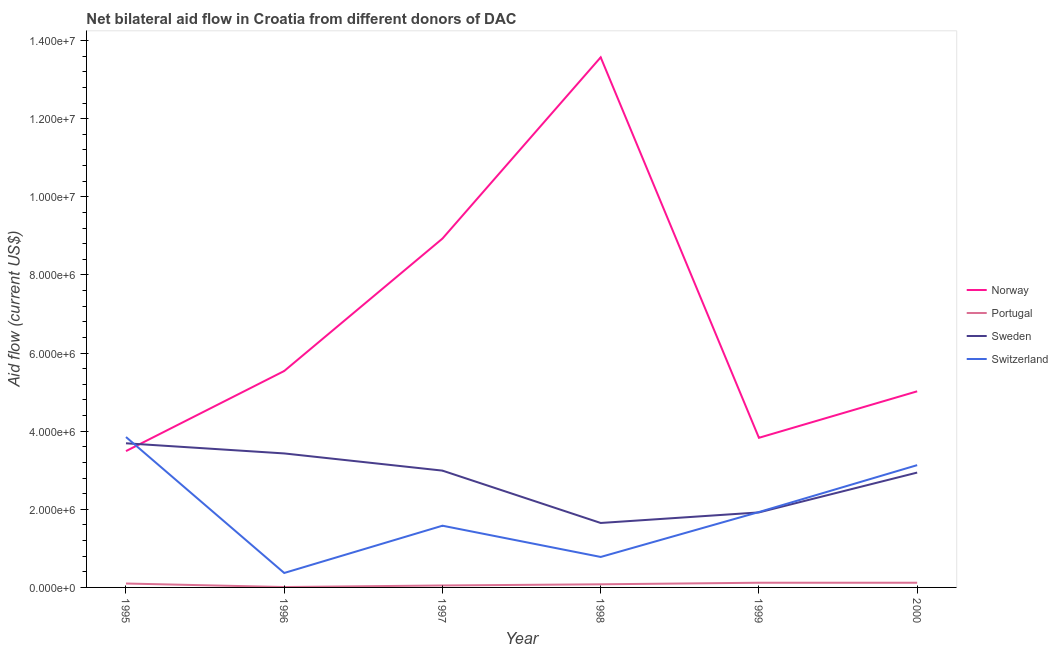How many different coloured lines are there?
Give a very brief answer. 4. Does the line corresponding to amount of aid given by norway intersect with the line corresponding to amount of aid given by sweden?
Make the answer very short. Yes. What is the amount of aid given by sweden in 1997?
Offer a very short reply. 2.99e+06. Across all years, what is the maximum amount of aid given by portugal?
Your answer should be compact. 1.20e+05. Across all years, what is the minimum amount of aid given by switzerland?
Offer a terse response. 3.70e+05. What is the total amount of aid given by norway in the graph?
Offer a very short reply. 4.04e+07. What is the difference between the amount of aid given by portugal in 1995 and that in 1996?
Give a very brief answer. 9.00e+04. What is the difference between the amount of aid given by portugal in 1997 and the amount of aid given by sweden in 1999?
Give a very brief answer. -1.87e+06. In the year 1996, what is the difference between the amount of aid given by switzerland and amount of aid given by sweden?
Provide a short and direct response. -3.06e+06. What is the ratio of the amount of aid given by switzerland in 1995 to that in 2000?
Keep it short and to the point. 1.23. What is the difference between the highest and the second highest amount of aid given by sweden?
Give a very brief answer. 2.60e+05. What is the difference between the highest and the lowest amount of aid given by sweden?
Give a very brief answer. 2.04e+06. Is the sum of the amount of aid given by switzerland in 1999 and 2000 greater than the maximum amount of aid given by portugal across all years?
Offer a very short reply. Yes. Is it the case that in every year, the sum of the amount of aid given by norway and amount of aid given by sweden is greater than the sum of amount of aid given by switzerland and amount of aid given by portugal?
Ensure brevity in your answer.  Yes. Is the amount of aid given by portugal strictly less than the amount of aid given by switzerland over the years?
Provide a short and direct response. Yes. How many lines are there?
Ensure brevity in your answer.  4. How many years are there in the graph?
Offer a very short reply. 6. What is the difference between two consecutive major ticks on the Y-axis?
Make the answer very short. 2.00e+06. Does the graph contain grids?
Your response must be concise. No. How are the legend labels stacked?
Ensure brevity in your answer.  Vertical. What is the title of the graph?
Your answer should be compact. Net bilateral aid flow in Croatia from different donors of DAC. What is the label or title of the X-axis?
Make the answer very short. Year. What is the Aid flow (current US$) in Norway in 1995?
Make the answer very short. 3.49e+06. What is the Aid flow (current US$) of Sweden in 1995?
Offer a very short reply. 3.69e+06. What is the Aid flow (current US$) in Switzerland in 1995?
Offer a terse response. 3.85e+06. What is the Aid flow (current US$) in Norway in 1996?
Provide a succinct answer. 5.54e+06. What is the Aid flow (current US$) of Sweden in 1996?
Offer a terse response. 3.43e+06. What is the Aid flow (current US$) of Norway in 1997?
Provide a succinct answer. 8.93e+06. What is the Aid flow (current US$) in Portugal in 1997?
Make the answer very short. 5.00e+04. What is the Aid flow (current US$) of Sweden in 1997?
Offer a very short reply. 2.99e+06. What is the Aid flow (current US$) in Switzerland in 1997?
Provide a short and direct response. 1.58e+06. What is the Aid flow (current US$) in Norway in 1998?
Offer a terse response. 1.36e+07. What is the Aid flow (current US$) in Portugal in 1998?
Ensure brevity in your answer.  8.00e+04. What is the Aid flow (current US$) of Sweden in 1998?
Give a very brief answer. 1.65e+06. What is the Aid flow (current US$) of Switzerland in 1998?
Your answer should be compact. 7.80e+05. What is the Aid flow (current US$) of Norway in 1999?
Give a very brief answer. 3.83e+06. What is the Aid flow (current US$) of Portugal in 1999?
Keep it short and to the point. 1.20e+05. What is the Aid flow (current US$) of Sweden in 1999?
Provide a succinct answer. 1.92e+06. What is the Aid flow (current US$) in Switzerland in 1999?
Give a very brief answer. 1.93e+06. What is the Aid flow (current US$) of Norway in 2000?
Provide a succinct answer. 5.02e+06. What is the Aid flow (current US$) of Portugal in 2000?
Provide a succinct answer. 1.20e+05. What is the Aid flow (current US$) of Sweden in 2000?
Ensure brevity in your answer.  2.94e+06. What is the Aid flow (current US$) of Switzerland in 2000?
Provide a succinct answer. 3.13e+06. Across all years, what is the maximum Aid flow (current US$) of Norway?
Provide a succinct answer. 1.36e+07. Across all years, what is the maximum Aid flow (current US$) in Sweden?
Give a very brief answer. 3.69e+06. Across all years, what is the maximum Aid flow (current US$) in Switzerland?
Provide a succinct answer. 3.85e+06. Across all years, what is the minimum Aid flow (current US$) in Norway?
Offer a very short reply. 3.49e+06. Across all years, what is the minimum Aid flow (current US$) in Portugal?
Your answer should be very brief. 10000. Across all years, what is the minimum Aid flow (current US$) of Sweden?
Your answer should be very brief. 1.65e+06. What is the total Aid flow (current US$) in Norway in the graph?
Offer a terse response. 4.04e+07. What is the total Aid flow (current US$) in Portugal in the graph?
Keep it short and to the point. 4.80e+05. What is the total Aid flow (current US$) of Sweden in the graph?
Keep it short and to the point. 1.66e+07. What is the total Aid flow (current US$) in Switzerland in the graph?
Give a very brief answer. 1.16e+07. What is the difference between the Aid flow (current US$) in Norway in 1995 and that in 1996?
Offer a terse response. -2.05e+06. What is the difference between the Aid flow (current US$) in Sweden in 1995 and that in 1996?
Your answer should be compact. 2.60e+05. What is the difference between the Aid flow (current US$) in Switzerland in 1995 and that in 1996?
Ensure brevity in your answer.  3.48e+06. What is the difference between the Aid flow (current US$) of Norway in 1995 and that in 1997?
Ensure brevity in your answer.  -5.44e+06. What is the difference between the Aid flow (current US$) in Switzerland in 1995 and that in 1997?
Offer a terse response. 2.27e+06. What is the difference between the Aid flow (current US$) of Norway in 1995 and that in 1998?
Offer a very short reply. -1.01e+07. What is the difference between the Aid flow (current US$) of Portugal in 1995 and that in 1998?
Make the answer very short. 2.00e+04. What is the difference between the Aid flow (current US$) in Sweden in 1995 and that in 1998?
Offer a terse response. 2.04e+06. What is the difference between the Aid flow (current US$) of Switzerland in 1995 and that in 1998?
Offer a very short reply. 3.07e+06. What is the difference between the Aid flow (current US$) of Norway in 1995 and that in 1999?
Provide a short and direct response. -3.40e+05. What is the difference between the Aid flow (current US$) of Portugal in 1995 and that in 1999?
Give a very brief answer. -2.00e+04. What is the difference between the Aid flow (current US$) of Sweden in 1995 and that in 1999?
Your response must be concise. 1.77e+06. What is the difference between the Aid flow (current US$) in Switzerland in 1995 and that in 1999?
Provide a short and direct response. 1.92e+06. What is the difference between the Aid flow (current US$) in Norway in 1995 and that in 2000?
Your answer should be very brief. -1.53e+06. What is the difference between the Aid flow (current US$) in Sweden in 1995 and that in 2000?
Ensure brevity in your answer.  7.50e+05. What is the difference between the Aid flow (current US$) in Switzerland in 1995 and that in 2000?
Provide a short and direct response. 7.20e+05. What is the difference between the Aid flow (current US$) in Norway in 1996 and that in 1997?
Provide a short and direct response. -3.39e+06. What is the difference between the Aid flow (current US$) in Sweden in 1996 and that in 1997?
Offer a very short reply. 4.40e+05. What is the difference between the Aid flow (current US$) in Switzerland in 1996 and that in 1997?
Your response must be concise. -1.21e+06. What is the difference between the Aid flow (current US$) in Norway in 1996 and that in 1998?
Provide a short and direct response. -8.03e+06. What is the difference between the Aid flow (current US$) of Sweden in 1996 and that in 1998?
Give a very brief answer. 1.78e+06. What is the difference between the Aid flow (current US$) in Switzerland in 1996 and that in 1998?
Your response must be concise. -4.10e+05. What is the difference between the Aid flow (current US$) in Norway in 1996 and that in 1999?
Your answer should be very brief. 1.71e+06. What is the difference between the Aid flow (current US$) in Portugal in 1996 and that in 1999?
Your answer should be compact. -1.10e+05. What is the difference between the Aid flow (current US$) of Sweden in 1996 and that in 1999?
Provide a succinct answer. 1.51e+06. What is the difference between the Aid flow (current US$) of Switzerland in 1996 and that in 1999?
Your answer should be compact. -1.56e+06. What is the difference between the Aid flow (current US$) in Norway in 1996 and that in 2000?
Your response must be concise. 5.20e+05. What is the difference between the Aid flow (current US$) in Switzerland in 1996 and that in 2000?
Your answer should be very brief. -2.76e+06. What is the difference between the Aid flow (current US$) of Norway in 1997 and that in 1998?
Make the answer very short. -4.64e+06. What is the difference between the Aid flow (current US$) in Sweden in 1997 and that in 1998?
Provide a succinct answer. 1.34e+06. What is the difference between the Aid flow (current US$) of Norway in 1997 and that in 1999?
Offer a terse response. 5.10e+06. What is the difference between the Aid flow (current US$) in Sweden in 1997 and that in 1999?
Ensure brevity in your answer.  1.07e+06. What is the difference between the Aid flow (current US$) of Switzerland in 1997 and that in 1999?
Give a very brief answer. -3.50e+05. What is the difference between the Aid flow (current US$) of Norway in 1997 and that in 2000?
Keep it short and to the point. 3.91e+06. What is the difference between the Aid flow (current US$) in Switzerland in 1997 and that in 2000?
Provide a succinct answer. -1.55e+06. What is the difference between the Aid flow (current US$) in Norway in 1998 and that in 1999?
Provide a succinct answer. 9.74e+06. What is the difference between the Aid flow (current US$) in Portugal in 1998 and that in 1999?
Your answer should be very brief. -4.00e+04. What is the difference between the Aid flow (current US$) of Sweden in 1998 and that in 1999?
Give a very brief answer. -2.70e+05. What is the difference between the Aid flow (current US$) in Switzerland in 1998 and that in 1999?
Your response must be concise. -1.15e+06. What is the difference between the Aid flow (current US$) in Norway in 1998 and that in 2000?
Ensure brevity in your answer.  8.55e+06. What is the difference between the Aid flow (current US$) of Sweden in 1998 and that in 2000?
Keep it short and to the point. -1.29e+06. What is the difference between the Aid flow (current US$) of Switzerland in 1998 and that in 2000?
Make the answer very short. -2.35e+06. What is the difference between the Aid flow (current US$) of Norway in 1999 and that in 2000?
Provide a succinct answer. -1.19e+06. What is the difference between the Aid flow (current US$) in Sweden in 1999 and that in 2000?
Offer a terse response. -1.02e+06. What is the difference between the Aid flow (current US$) of Switzerland in 1999 and that in 2000?
Ensure brevity in your answer.  -1.20e+06. What is the difference between the Aid flow (current US$) in Norway in 1995 and the Aid flow (current US$) in Portugal in 1996?
Ensure brevity in your answer.  3.48e+06. What is the difference between the Aid flow (current US$) of Norway in 1995 and the Aid flow (current US$) of Switzerland in 1996?
Make the answer very short. 3.12e+06. What is the difference between the Aid flow (current US$) of Portugal in 1995 and the Aid flow (current US$) of Sweden in 1996?
Keep it short and to the point. -3.33e+06. What is the difference between the Aid flow (current US$) of Portugal in 1995 and the Aid flow (current US$) of Switzerland in 1996?
Your answer should be very brief. -2.70e+05. What is the difference between the Aid flow (current US$) of Sweden in 1995 and the Aid flow (current US$) of Switzerland in 1996?
Your response must be concise. 3.32e+06. What is the difference between the Aid flow (current US$) in Norway in 1995 and the Aid flow (current US$) in Portugal in 1997?
Your answer should be very brief. 3.44e+06. What is the difference between the Aid flow (current US$) in Norway in 1995 and the Aid flow (current US$) in Sweden in 1997?
Provide a succinct answer. 5.00e+05. What is the difference between the Aid flow (current US$) of Norway in 1995 and the Aid flow (current US$) of Switzerland in 1997?
Offer a terse response. 1.91e+06. What is the difference between the Aid flow (current US$) of Portugal in 1995 and the Aid flow (current US$) of Sweden in 1997?
Make the answer very short. -2.89e+06. What is the difference between the Aid flow (current US$) of Portugal in 1995 and the Aid flow (current US$) of Switzerland in 1997?
Provide a short and direct response. -1.48e+06. What is the difference between the Aid flow (current US$) of Sweden in 1995 and the Aid flow (current US$) of Switzerland in 1997?
Ensure brevity in your answer.  2.11e+06. What is the difference between the Aid flow (current US$) of Norway in 1995 and the Aid flow (current US$) of Portugal in 1998?
Offer a very short reply. 3.41e+06. What is the difference between the Aid flow (current US$) of Norway in 1995 and the Aid flow (current US$) of Sweden in 1998?
Ensure brevity in your answer.  1.84e+06. What is the difference between the Aid flow (current US$) of Norway in 1995 and the Aid flow (current US$) of Switzerland in 1998?
Ensure brevity in your answer.  2.71e+06. What is the difference between the Aid flow (current US$) in Portugal in 1995 and the Aid flow (current US$) in Sweden in 1998?
Your answer should be very brief. -1.55e+06. What is the difference between the Aid flow (current US$) in Portugal in 1995 and the Aid flow (current US$) in Switzerland in 1998?
Offer a very short reply. -6.80e+05. What is the difference between the Aid flow (current US$) in Sweden in 1995 and the Aid flow (current US$) in Switzerland in 1998?
Ensure brevity in your answer.  2.91e+06. What is the difference between the Aid flow (current US$) of Norway in 1995 and the Aid flow (current US$) of Portugal in 1999?
Provide a succinct answer. 3.37e+06. What is the difference between the Aid flow (current US$) of Norway in 1995 and the Aid flow (current US$) of Sweden in 1999?
Provide a succinct answer. 1.57e+06. What is the difference between the Aid flow (current US$) in Norway in 1995 and the Aid flow (current US$) in Switzerland in 1999?
Your answer should be very brief. 1.56e+06. What is the difference between the Aid flow (current US$) of Portugal in 1995 and the Aid flow (current US$) of Sweden in 1999?
Provide a short and direct response. -1.82e+06. What is the difference between the Aid flow (current US$) in Portugal in 1995 and the Aid flow (current US$) in Switzerland in 1999?
Provide a short and direct response. -1.83e+06. What is the difference between the Aid flow (current US$) in Sweden in 1995 and the Aid flow (current US$) in Switzerland in 1999?
Ensure brevity in your answer.  1.76e+06. What is the difference between the Aid flow (current US$) of Norway in 1995 and the Aid flow (current US$) of Portugal in 2000?
Offer a very short reply. 3.37e+06. What is the difference between the Aid flow (current US$) of Norway in 1995 and the Aid flow (current US$) of Sweden in 2000?
Give a very brief answer. 5.50e+05. What is the difference between the Aid flow (current US$) of Portugal in 1995 and the Aid flow (current US$) of Sweden in 2000?
Provide a succinct answer. -2.84e+06. What is the difference between the Aid flow (current US$) in Portugal in 1995 and the Aid flow (current US$) in Switzerland in 2000?
Provide a short and direct response. -3.03e+06. What is the difference between the Aid flow (current US$) of Sweden in 1995 and the Aid flow (current US$) of Switzerland in 2000?
Your answer should be very brief. 5.60e+05. What is the difference between the Aid flow (current US$) of Norway in 1996 and the Aid flow (current US$) of Portugal in 1997?
Provide a short and direct response. 5.49e+06. What is the difference between the Aid flow (current US$) in Norway in 1996 and the Aid flow (current US$) in Sweden in 1997?
Your answer should be compact. 2.55e+06. What is the difference between the Aid flow (current US$) in Norway in 1996 and the Aid flow (current US$) in Switzerland in 1997?
Your answer should be very brief. 3.96e+06. What is the difference between the Aid flow (current US$) of Portugal in 1996 and the Aid flow (current US$) of Sweden in 1997?
Your response must be concise. -2.98e+06. What is the difference between the Aid flow (current US$) of Portugal in 1996 and the Aid flow (current US$) of Switzerland in 1997?
Offer a very short reply. -1.57e+06. What is the difference between the Aid flow (current US$) of Sweden in 1996 and the Aid flow (current US$) of Switzerland in 1997?
Your answer should be very brief. 1.85e+06. What is the difference between the Aid flow (current US$) in Norway in 1996 and the Aid flow (current US$) in Portugal in 1998?
Keep it short and to the point. 5.46e+06. What is the difference between the Aid flow (current US$) of Norway in 1996 and the Aid flow (current US$) of Sweden in 1998?
Your answer should be compact. 3.89e+06. What is the difference between the Aid flow (current US$) in Norway in 1996 and the Aid flow (current US$) in Switzerland in 1998?
Give a very brief answer. 4.76e+06. What is the difference between the Aid flow (current US$) in Portugal in 1996 and the Aid flow (current US$) in Sweden in 1998?
Your response must be concise. -1.64e+06. What is the difference between the Aid flow (current US$) of Portugal in 1996 and the Aid flow (current US$) of Switzerland in 1998?
Give a very brief answer. -7.70e+05. What is the difference between the Aid flow (current US$) in Sweden in 1996 and the Aid flow (current US$) in Switzerland in 1998?
Offer a very short reply. 2.65e+06. What is the difference between the Aid flow (current US$) in Norway in 1996 and the Aid flow (current US$) in Portugal in 1999?
Provide a succinct answer. 5.42e+06. What is the difference between the Aid flow (current US$) in Norway in 1996 and the Aid flow (current US$) in Sweden in 1999?
Ensure brevity in your answer.  3.62e+06. What is the difference between the Aid flow (current US$) of Norway in 1996 and the Aid flow (current US$) of Switzerland in 1999?
Provide a succinct answer. 3.61e+06. What is the difference between the Aid flow (current US$) of Portugal in 1996 and the Aid flow (current US$) of Sweden in 1999?
Your response must be concise. -1.91e+06. What is the difference between the Aid flow (current US$) in Portugal in 1996 and the Aid flow (current US$) in Switzerland in 1999?
Keep it short and to the point. -1.92e+06. What is the difference between the Aid flow (current US$) in Sweden in 1996 and the Aid flow (current US$) in Switzerland in 1999?
Make the answer very short. 1.50e+06. What is the difference between the Aid flow (current US$) in Norway in 1996 and the Aid flow (current US$) in Portugal in 2000?
Provide a succinct answer. 5.42e+06. What is the difference between the Aid flow (current US$) in Norway in 1996 and the Aid flow (current US$) in Sweden in 2000?
Offer a very short reply. 2.60e+06. What is the difference between the Aid flow (current US$) in Norway in 1996 and the Aid flow (current US$) in Switzerland in 2000?
Make the answer very short. 2.41e+06. What is the difference between the Aid flow (current US$) of Portugal in 1996 and the Aid flow (current US$) of Sweden in 2000?
Your answer should be very brief. -2.93e+06. What is the difference between the Aid flow (current US$) of Portugal in 1996 and the Aid flow (current US$) of Switzerland in 2000?
Your answer should be compact. -3.12e+06. What is the difference between the Aid flow (current US$) in Sweden in 1996 and the Aid flow (current US$) in Switzerland in 2000?
Your answer should be compact. 3.00e+05. What is the difference between the Aid flow (current US$) in Norway in 1997 and the Aid flow (current US$) in Portugal in 1998?
Offer a very short reply. 8.85e+06. What is the difference between the Aid flow (current US$) of Norway in 1997 and the Aid flow (current US$) of Sweden in 1998?
Keep it short and to the point. 7.28e+06. What is the difference between the Aid flow (current US$) of Norway in 1997 and the Aid flow (current US$) of Switzerland in 1998?
Give a very brief answer. 8.15e+06. What is the difference between the Aid flow (current US$) of Portugal in 1997 and the Aid flow (current US$) of Sweden in 1998?
Provide a succinct answer. -1.60e+06. What is the difference between the Aid flow (current US$) in Portugal in 1997 and the Aid flow (current US$) in Switzerland in 1998?
Make the answer very short. -7.30e+05. What is the difference between the Aid flow (current US$) in Sweden in 1997 and the Aid flow (current US$) in Switzerland in 1998?
Provide a succinct answer. 2.21e+06. What is the difference between the Aid flow (current US$) in Norway in 1997 and the Aid flow (current US$) in Portugal in 1999?
Provide a succinct answer. 8.81e+06. What is the difference between the Aid flow (current US$) in Norway in 1997 and the Aid flow (current US$) in Sweden in 1999?
Give a very brief answer. 7.01e+06. What is the difference between the Aid flow (current US$) of Portugal in 1997 and the Aid flow (current US$) of Sweden in 1999?
Offer a terse response. -1.87e+06. What is the difference between the Aid flow (current US$) in Portugal in 1997 and the Aid flow (current US$) in Switzerland in 1999?
Keep it short and to the point. -1.88e+06. What is the difference between the Aid flow (current US$) of Sweden in 1997 and the Aid flow (current US$) of Switzerland in 1999?
Ensure brevity in your answer.  1.06e+06. What is the difference between the Aid flow (current US$) in Norway in 1997 and the Aid flow (current US$) in Portugal in 2000?
Offer a very short reply. 8.81e+06. What is the difference between the Aid flow (current US$) in Norway in 1997 and the Aid flow (current US$) in Sweden in 2000?
Give a very brief answer. 5.99e+06. What is the difference between the Aid flow (current US$) of Norway in 1997 and the Aid flow (current US$) of Switzerland in 2000?
Give a very brief answer. 5.80e+06. What is the difference between the Aid flow (current US$) of Portugal in 1997 and the Aid flow (current US$) of Sweden in 2000?
Keep it short and to the point. -2.89e+06. What is the difference between the Aid flow (current US$) in Portugal in 1997 and the Aid flow (current US$) in Switzerland in 2000?
Make the answer very short. -3.08e+06. What is the difference between the Aid flow (current US$) of Norway in 1998 and the Aid flow (current US$) of Portugal in 1999?
Your answer should be very brief. 1.34e+07. What is the difference between the Aid flow (current US$) in Norway in 1998 and the Aid flow (current US$) in Sweden in 1999?
Your answer should be compact. 1.16e+07. What is the difference between the Aid flow (current US$) in Norway in 1998 and the Aid flow (current US$) in Switzerland in 1999?
Ensure brevity in your answer.  1.16e+07. What is the difference between the Aid flow (current US$) of Portugal in 1998 and the Aid flow (current US$) of Sweden in 1999?
Make the answer very short. -1.84e+06. What is the difference between the Aid flow (current US$) in Portugal in 1998 and the Aid flow (current US$) in Switzerland in 1999?
Make the answer very short. -1.85e+06. What is the difference between the Aid flow (current US$) of Sweden in 1998 and the Aid flow (current US$) of Switzerland in 1999?
Your answer should be very brief. -2.80e+05. What is the difference between the Aid flow (current US$) in Norway in 1998 and the Aid flow (current US$) in Portugal in 2000?
Your response must be concise. 1.34e+07. What is the difference between the Aid flow (current US$) in Norway in 1998 and the Aid flow (current US$) in Sweden in 2000?
Provide a succinct answer. 1.06e+07. What is the difference between the Aid flow (current US$) in Norway in 1998 and the Aid flow (current US$) in Switzerland in 2000?
Your answer should be compact. 1.04e+07. What is the difference between the Aid flow (current US$) in Portugal in 1998 and the Aid flow (current US$) in Sweden in 2000?
Provide a short and direct response. -2.86e+06. What is the difference between the Aid flow (current US$) of Portugal in 1998 and the Aid flow (current US$) of Switzerland in 2000?
Make the answer very short. -3.05e+06. What is the difference between the Aid flow (current US$) of Sweden in 1998 and the Aid flow (current US$) of Switzerland in 2000?
Provide a succinct answer. -1.48e+06. What is the difference between the Aid flow (current US$) in Norway in 1999 and the Aid flow (current US$) in Portugal in 2000?
Make the answer very short. 3.71e+06. What is the difference between the Aid flow (current US$) in Norway in 1999 and the Aid flow (current US$) in Sweden in 2000?
Offer a terse response. 8.90e+05. What is the difference between the Aid flow (current US$) of Norway in 1999 and the Aid flow (current US$) of Switzerland in 2000?
Your response must be concise. 7.00e+05. What is the difference between the Aid flow (current US$) of Portugal in 1999 and the Aid flow (current US$) of Sweden in 2000?
Your response must be concise. -2.82e+06. What is the difference between the Aid flow (current US$) of Portugal in 1999 and the Aid flow (current US$) of Switzerland in 2000?
Offer a terse response. -3.01e+06. What is the difference between the Aid flow (current US$) in Sweden in 1999 and the Aid flow (current US$) in Switzerland in 2000?
Your response must be concise. -1.21e+06. What is the average Aid flow (current US$) of Norway per year?
Keep it short and to the point. 6.73e+06. What is the average Aid flow (current US$) of Sweden per year?
Provide a succinct answer. 2.77e+06. What is the average Aid flow (current US$) of Switzerland per year?
Offer a very short reply. 1.94e+06. In the year 1995, what is the difference between the Aid flow (current US$) of Norway and Aid flow (current US$) of Portugal?
Offer a terse response. 3.39e+06. In the year 1995, what is the difference between the Aid flow (current US$) in Norway and Aid flow (current US$) in Sweden?
Provide a succinct answer. -2.00e+05. In the year 1995, what is the difference between the Aid flow (current US$) of Norway and Aid flow (current US$) of Switzerland?
Provide a short and direct response. -3.60e+05. In the year 1995, what is the difference between the Aid flow (current US$) in Portugal and Aid flow (current US$) in Sweden?
Make the answer very short. -3.59e+06. In the year 1995, what is the difference between the Aid flow (current US$) in Portugal and Aid flow (current US$) in Switzerland?
Keep it short and to the point. -3.75e+06. In the year 1995, what is the difference between the Aid flow (current US$) in Sweden and Aid flow (current US$) in Switzerland?
Offer a terse response. -1.60e+05. In the year 1996, what is the difference between the Aid flow (current US$) of Norway and Aid flow (current US$) of Portugal?
Offer a terse response. 5.53e+06. In the year 1996, what is the difference between the Aid flow (current US$) of Norway and Aid flow (current US$) of Sweden?
Your answer should be compact. 2.11e+06. In the year 1996, what is the difference between the Aid flow (current US$) of Norway and Aid flow (current US$) of Switzerland?
Your answer should be compact. 5.17e+06. In the year 1996, what is the difference between the Aid flow (current US$) in Portugal and Aid flow (current US$) in Sweden?
Make the answer very short. -3.42e+06. In the year 1996, what is the difference between the Aid flow (current US$) in Portugal and Aid flow (current US$) in Switzerland?
Provide a short and direct response. -3.60e+05. In the year 1996, what is the difference between the Aid flow (current US$) in Sweden and Aid flow (current US$) in Switzerland?
Make the answer very short. 3.06e+06. In the year 1997, what is the difference between the Aid flow (current US$) in Norway and Aid flow (current US$) in Portugal?
Make the answer very short. 8.88e+06. In the year 1997, what is the difference between the Aid flow (current US$) in Norway and Aid flow (current US$) in Sweden?
Offer a terse response. 5.94e+06. In the year 1997, what is the difference between the Aid flow (current US$) in Norway and Aid flow (current US$) in Switzerland?
Offer a terse response. 7.35e+06. In the year 1997, what is the difference between the Aid flow (current US$) of Portugal and Aid flow (current US$) of Sweden?
Provide a short and direct response. -2.94e+06. In the year 1997, what is the difference between the Aid flow (current US$) in Portugal and Aid flow (current US$) in Switzerland?
Offer a terse response. -1.53e+06. In the year 1997, what is the difference between the Aid flow (current US$) of Sweden and Aid flow (current US$) of Switzerland?
Provide a succinct answer. 1.41e+06. In the year 1998, what is the difference between the Aid flow (current US$) in Norway and Aid flow (current US$) in Portugal?
Offer a terse response. 1.35e+07. In the year 1998, what is the difference between the Aid flow (current US$) of Norway and Aid flow (current US$) of Sweden?
Your answer should be compact. 1.19e+07. In the year 1998, what is the difference between the Aid flow (current US$) of Norway and Aid flow (current US$) of Switzerland?
Offer a terse response. 1.28e+07. In the year 1998, what is the difference between the Aid flow (current US$) of Portugal and Aid flow (current US$) of Sweden?
Ensure brevity in your answer.  -1.57e+06. In the year 1998, what is the difference between the Aid flow (current US$) in Portugal and Aid flow (current US$) in Switzerland?
Keep it short and to the point. -7.00e+05. In the year 1998, what is the difference between the Aid flow (current US$) of Sweden and Aid flow (current US$) of Switzerland?
Offer a very short reply. 8.70e+05. In the year 1999, what is the difference between the Aid flow (current US$) of Norway and Aid flow (current US$) of Portugal?
Your response must be concise. 3.71e+06. In the year 1999, what is the difference between the Aid flow (current US$) in Norway and Aid flow (current US$) in Sweden?
Make the answer very short. 1.91e+06. In the year 1999, what is the difference between the Aid flow (current US$) in Norway and Aid flow (current US$) in Switzerland?
Make the answer very short. 1.90e+06. In the year 1999, what is the difference between the Aid flow (current US$) in Portugal and Aid flow (current US$) in Sweden?
Keep it short and to the point. -1.80e+06. In the year 1999, what is the difference between the Aid flow (current US$) of Portugal and Aid flow (current US$) of Switzerland?
Your response must be concise. -1.81e+06. In the year 1999, what is the difference between the Aid flow (current US$) of Sweden and Aid flow (current US$) of Switzerland?
Keep it short and to the point. -10000. In the year 2000, what is the difference between the Aid flow (current US$) of Norway and Aid flow (current US$) of Portugal?
Ensure brevity in your answer.  4.90e+06. In the year 2000, what is the difference between the Aid flow (current US$) of Norway and Aid flow (current US$) of Sweden?
Make the answer very short. 2.08e+06. In the year 2000, what is the difference between the Aid flow (current US$) of Norway and Aid flow (current US$) of Switzerland?
Your answer should be very brief. 1.89e+06. In the year 2000, what is the difference between the Aid flow (current US$) of Portugal and Aid flow (current US$) of Sweden?
Ensure brevity in your answer.  -2.82e+06. In the year 2000, what is the difference between the Aid flow (current US$) in Portugal and Aid flow (current US$) in Switzerland?
Provide a succinct answer. -3.01e+06. What is the ratio of the Aid flow (current US$) in Norway in 1995 to that in 1996?
Give a very brief answer. 0.63. What is the ratio of the Aid flow (current US$) of Sweden in 1995 to that in 1996?
Provide a short and direct response. 1.08. What is the ratio of the Aid flow (current US$) of Switzerland in 1995 to that in 1996?
Make the answer very short. 10.41. What is the ratio of the Aid flow (current US$) in Norway in 1995 to that in 1997?
Offer a terse response. 0.39. What is the ratio of the Aid flow (current US$) of Portugal in 1995 to that in 1997?
Ensure brevity in your answer.  2. What is the ratio of the Aid flow (current US$) in Sweden in 1995 to that in 1997?
Your answer should be very brief. 1.23. What is the ratio of the Aid flow (current US$) of Switzerland in 1995 to that in 1997?
Give a very brief answer. 2.44. What is the ratio of the Aid flow (current US$) in Norway in 1995 to that in 1998?
Your answer should be very brief. 0.26. What is the ratio of the Aid flow (current US$) of Sweden in 1995 to that in 1998?
Provide a succinct answer. 2.24. What is the ratio of the Aid flow (current US$) in Switzerland in 1995 to that in 1998?
Provide a succinct answer. 4.94. What is the ratio of the Aid flow (current US$) in Norway in 1995 to that in 1999?
Provide a short and direct response. 0.91. What is the ratio of the Aid flow (current US$) in Portugal in 1995 to that in 1999?
Provide a short and direct response. 0.83. What is the ratio of the Aid flow (current US$) of Sweden in 1995 to that in 1999?
Keep it short and to the point. 1.92. What is the ratio of the Aid flow (current US$) of Switzerland in 1995 to that in 1999?
Give a very brief answer. 1.99. What is the ratio of the Aid flow (current US$) of Norway in 1995 to that in 2000?
Your response must be concise. 0.7. What is the ratio of the Aid flow (current US$) in Sweden in 1995 to that in 2000?
Make the answer very short. 1.26. What is the ratio of the Aid flow (current US$) in Switzerland in 1995 to that in 2000?
Keep it short and to the point. 1.23. What is the ratio of the Aid flow (current US$) in Norway in 1996 to that in 1997?
Ensure brevity in your answer.  0.62. What is the ratio of the Aid flow (current US$) of Portugal in 1996 to that in 1997?
Your answer should be very brief. 0.2. What is the ratio of the Aid flow (current US$) of Sweden in 1996 to that in 1997?
Provide a short and direct response. 1.15. What is the ratio of the Aid flow (current US$) of Switzerland in 1996 to that in 1997?
Keep it short and to the point. 0.23. What is the ratio of the Aid flow (current US$) of Norway in 1996 to that in 1998?
Offer a terse response. 0.41. What is the ratio of the Aid flow (current US$) in Portugal in 1996 to that in 1998?
Give a very brief answer. 0.12. What is the ratio of the Aid flow (current US$) of Sweden in 1996 to that in 1998?
Make the answer very short. 2.08. What is the ratio of the Aid flow (current US$) of Switzerland in 1996 to that in 1998?
Offer a very short reply. 0.47. What is the ratio of the Aid flow (current US$) in Norway in 1996 to that in 1999?
Your answer should be compact. 1.45. What is the ratio of the Aid flow (current US$) of Portugal in 1996 to that in 1999?
Offer a terse response. 0.08. What is the ratio of the Aid flow (current US$) of Sweden in 1996 to that in 1999?
Give a very brief answer. 1.79. What is the ratio of the Aid flow (current US$) in Switzerland in 1996 to that in 1999?
Offer a terse response. 0.19. What is the ratio of the Aid flow (current US$) of Norway in 1996 to that in 2000?
Ensure brevity in your answer.  1.1. What is the ratio of the Aid flow (current US$) of Portugal in 1996 to that in 2000?
Provide a short and direct response. 0.08. What is the ratio of the Aid flow (current US$) of Sweden in 1996 to that in 2000?
Your answer should be compact. 1.17. What is the ratio of the Aid flow (current US$) in Switzerland in 1996 to that in 2000?
Offer a terse response. 0.12. What is the ratio of the Aid flow (current US$) of Norway in 1997 to that in 1998?
Provide a succinct answer. 0.66. What is the ratio of the Aid flow (current US$) of Sweden in 1997 to that in 1998?
Ensure brevity in your answer.  1.81. What is the ratio of the Aid flow (current US$) in Switzerland in 1997 to that in 1998?
Provide a succinct answer. 2.03. What is the ratio of the Aid flow (current US$) of Norway in 1997 to that in 1999?
Give a very brief answer. 2.33. What is the ratio of the Aid flow (current US$) of Portugal in 1997 to that in 1999?
Offer a terse response. 0.42. What is the ratio of the Aid flow (current US$) of Sweden in 1997 to that in 1999?
Your answer should be very brief. 1.56. What is the ratio of the Aid flow (current US$) of Switzerland in 1997 to that in 1999?
Provide a succinct answer. 0.82. What is the ratio of the Aid flow (current US$) of Norway in 1997 to that in 2000?
Your answer should be compact. 1.78. What is the ratio of the Aid flow (current US$) in Portugal in 1997 to that in 2000?
Keep it short and to the point. 0.42. What is the ratio of the Aid flow (current US$) of Sweden in 1997 to that in 2000?
Make the answer very short. 1.02. What is the ratio of the Aid flow (current US$) in Switzerland in 1997 to that in 2000?
Keep it short and to the point. 0.5. What is the ratio of the Aid flow (current US$) of Norway in 1998 to that in 1999?
Make the answer very short. 3.54. What is the ratio of the Aid flow (current US$) of Sweden in 1998 to that in 1999?
Your answer should be very brief. 0.86. What is the ratio of the Aid flow (current US$) of Switzerland in 1998 to that in 1999?
Make the answer very short. 0.4. What is the ratio of the Aid flow (current US$) in Norway in 1998 to that in 2000?
Offer a terse response. 2.7. What is the ratio of the Aid flow (current US$) in Sweden in 1998 to that in 2000?
Your answer should be compact. 0.56. What is the ratio of the Aid flow (current US$) in Switzerland in 1998 to that in 2000?
Your response must be concise. 0.25. What is the ratio of the Aid flow (current US$) in Norway in 1999 to that in 2000?
Ensure brevity in your answer.  0.76. What is the ratio of the Aid flow (current US$) in Portugal in 1999 to that in 2000?
Your answer should be compact. 1. What is the ratio of the Aid flow (current US$) of Sweden in 1999 to that in 2000?
Offer a terse response. 0.65. What is the ratio of the Aid flow (current US$) of Switzerland in 1999 to that in 2000?
Offer a terse response. 0.62. What is the difference between the highest and the second highest Aid flow (current US$) in Norway?
Offer a very short reply. 4.64e+06. What is the difference between the highest and the second highest Aid flow (current US$) of Sweden?
Make the answer very short. 2.60e+05. What is the difference between the highest and the second highest Aid flow (current US$) in Switzerland?
Offer a very short reply. 7.20e+05. What is the difference between the highest and the lowest Aid flow (current US$) of Norway?
Give a very brief answer. 1.01e+07. What is the difference between the highest and the lowest Aid flow (current US$) of Portugal?
Offer a terse response. 1.10e+05. What is the difference between the highest and the lowest Aid flow (current US$) in Sweden?
Your answer should be very brief. 2.04e+06. What is the difference between the highest and the lowest Aid flow (current US$) of Switzerland?
Ensure brevity in your answer.  3.48e+06. 